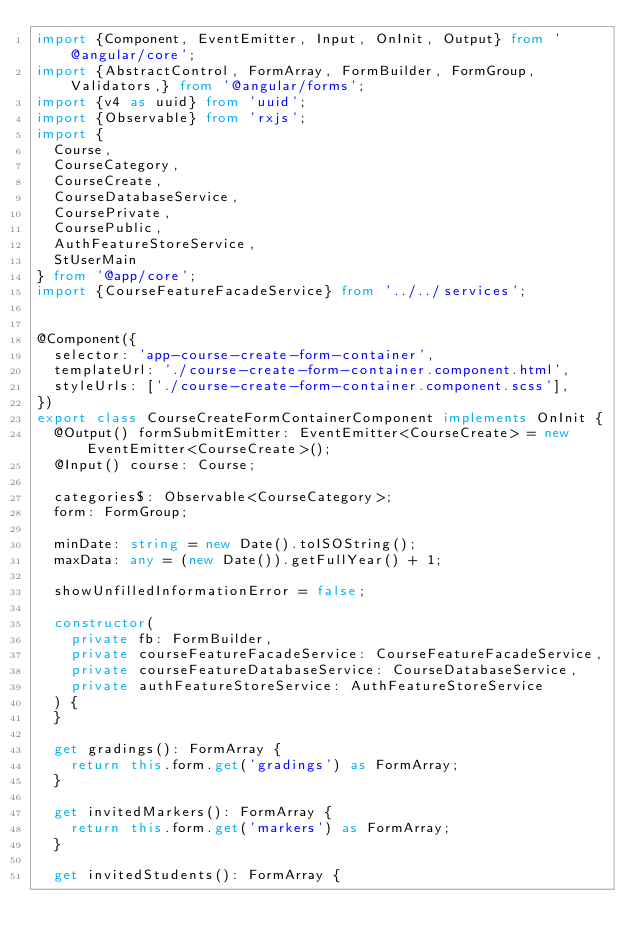<code> <loc_0><loc_0><loc_500><loc_500><_TypeScript_>import {Component, EventEmitter, Input, OnInit, Output} from '@angular/core';
import {AbstractControl, FormArray, FormBuilder, FormGroup, Validators,} from '@angular/forms';
import {v4 as uuid} from 'uuid';
import {Observable} from 'rxjs';
import {
  Course,
  CourseCategory,
  CourseCreate,
  CourseDatabaseService,
  CoursePrivate,
  CoursePublic,
  AuthFeatureStoreService,
  StUserMain
} from '@app/core';
import {CourseFeatureFacadeService} from '../../services';


@Component({
  selector: 'app-course-create-form-container',
  templateUrl: './course-create-form-container.component.html',
  styleUrls: ['./course-create-form-container.component.scss'],
})
export class CourseCreateFormContainerComponent implements OnInit {
  @Output() formSubmitEmitter: EventEmitter<CourseCreate> = new EventEmitter<CourseCreate>();
  @Input() course: Course;

  categories$: Observable<CourseCategory>;
  form: FormGroup;

  minDate: string = new Date().toISOString();
  maxData: any = (new Date()).getFullYear() + 1;

  showUnfilledInformationError = false;

  constructor(
    private fb: FormBuilder,
    private courseFeatureFacadeService: CourseFeatureFacadeService,
    private courseFeatureDatabaseService: CourseDatabaseService,
    private authFeatureStoreService: AuthFeatureStoreService
  ) {
  }

  get gradings(): FormArray {
    return this.form.get('gradings') as FormArray;
  }

  get invitedMarkers(): FormArray {
    return this.form.get('markers') as FormArray;
  }

  get invitedStudents(): FormArray {</code> 